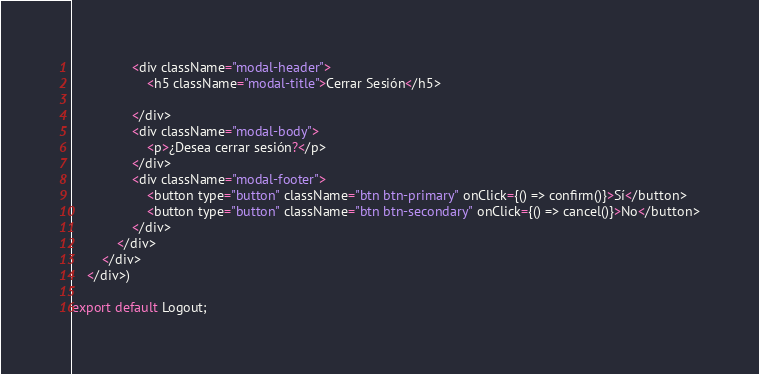<code> <loc_0><loc_0><loc_500><loc_500><_JavaScript_>                <div className="modal-header">
                    <h5 className="modal-title">Cerrar Sesión</h5>

                </div>
                <div className="modal-body">
                    <p>¿Desea cerrar sesión?</p>
                </div>
                <div className="modal-footer">
                    <button type="button" className="btn btn-primary" onClick={() => confirm()}>Sí</button>
                    <button type="button" className="btn btn-secondary" onClick={() => cancel()}>No</button>
                </div>
            </div>
        </div>
    </div>)

export default Logout;</code> 